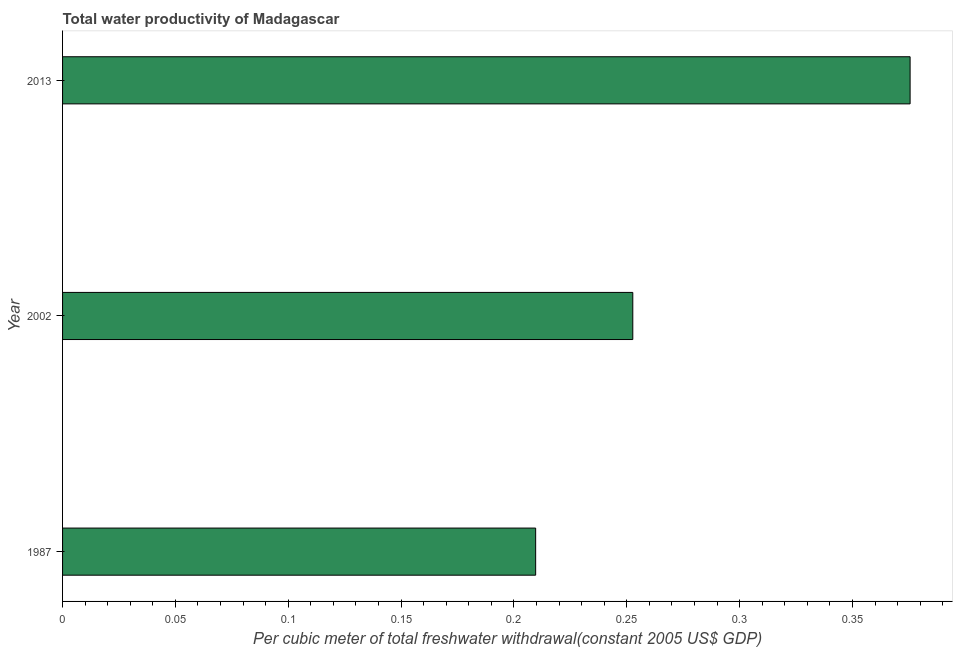Does the graph contain grids?
Offer a terse response. No. What is the title of the graph?
Your answer should be very brief. Total water productivity of Madagascar. What is the label or title of the X-axis?
Provide a succinct answer. Per cubic meter of total freshwater withdrawal(constant 2005 US$ GDP). What is the label or title of the Y-axis?
Offer a terse response. Year. What is the total water productivity in 1987?
Give a very brief answer. 0.21. Across all years, what is the maximum total water productivity?
Your answer should be very brief. 0.38. Across all years, what is the minimum total water productivity?
Your response must be concise. 0.21. In which year was the total water productivity maximum?
Your answer should be very brief. 2013. What is the sum of the total water productivity?
Your answer should be compact. 0.84. What is the difference between the total water productivity in 1987 and 2002?
Make the answer very short. -0.04. What is the average total water productivity per year?
Offer a terse response. 0.28. What is the median total water productivity?
Offer a very short reply. 0.25. In how many years, is the total water productivity greater than 0.35 US$?
Give a very brief answer. 1. Do a majority of the years between 1987 and 2013 (inclusive) have total water productivity greater than 0.06 US$?
Your answer should be very brief. Yes. What is the ratio of the total water productivity in 2002 to that in 2013?
Make the answer very short. 0.67. What is the difference between the highest and the second highest total water productivity?
Offer a terse response. 0.12. Is the sum of the total water productivity in 1987 and 2002 greater than the maximum total water productivity across all years?
Offer a very short reply. Yes. What is the difference between the highest and the lowest total water productivity?
Keep it short and to the point. 0.17. In how many years, is the total water productivity greater than the average total water productivity taken over all years?
Make the answer very short. 1. How many bars are there?
Give a very brief answer. 3. Are all the bars in the graph horizontal?
Provide a succinct answer. Yes. How many years are there in the graph?
Your answer should be compact. 3. What is the difference between two consecutive major ticks on the X-axis?
Your response must be concise. 0.05. What is the Per cubic meter of total freshwater withdrawal(constant 2005 US$ GDP) of 1987?
Your answer should be very brief. 0.21. What is the Per cubic meter of total freshwater withdrawal(constant 2005 US$ GDP) in 2002?
Make the answer very short. 0.25. What is the Per cubic meter of total freshwater withdrawal(constant 2005 US$ GDP) of 2013?
Make the answer very short. 0.38. What is the difference between the Per cubic meter of total freshwater withdrawal(constant 2005 US$ GDP) in 1987 and 2002?
Keep it short and to the point. -0.04. What is the difference between the Per cubic meter of total freshwater withdrawal(constant 2005 US$ GDP) in 1987 and 2013?
Your answer should be very brief. -0.17. What is the difference between the Per cubic meter of total freshwater withdrawal(constant 2005 US$ GDP) in 2002 and 2013?
Ensure brevity in your answer.  -0.12. What is the ratio of the Per cubic meter of total freshwater withdrawal(constant 2005 US$ GDP) in 1987 to that in 2002?
Make the answer very short. 0.83. What is the ratio of the Per cubic meter of total freshwater withdrawal(constant 2005 US$ GDP) in 1987 to that in 2013?
Make the answer very short. 0.56. What is the ratio of the Per cubic meter of total freshwater withdrawal(constant 2005 US$ GDP) in 2002 to that in 2013?
Offer a terse response. 0.67. 